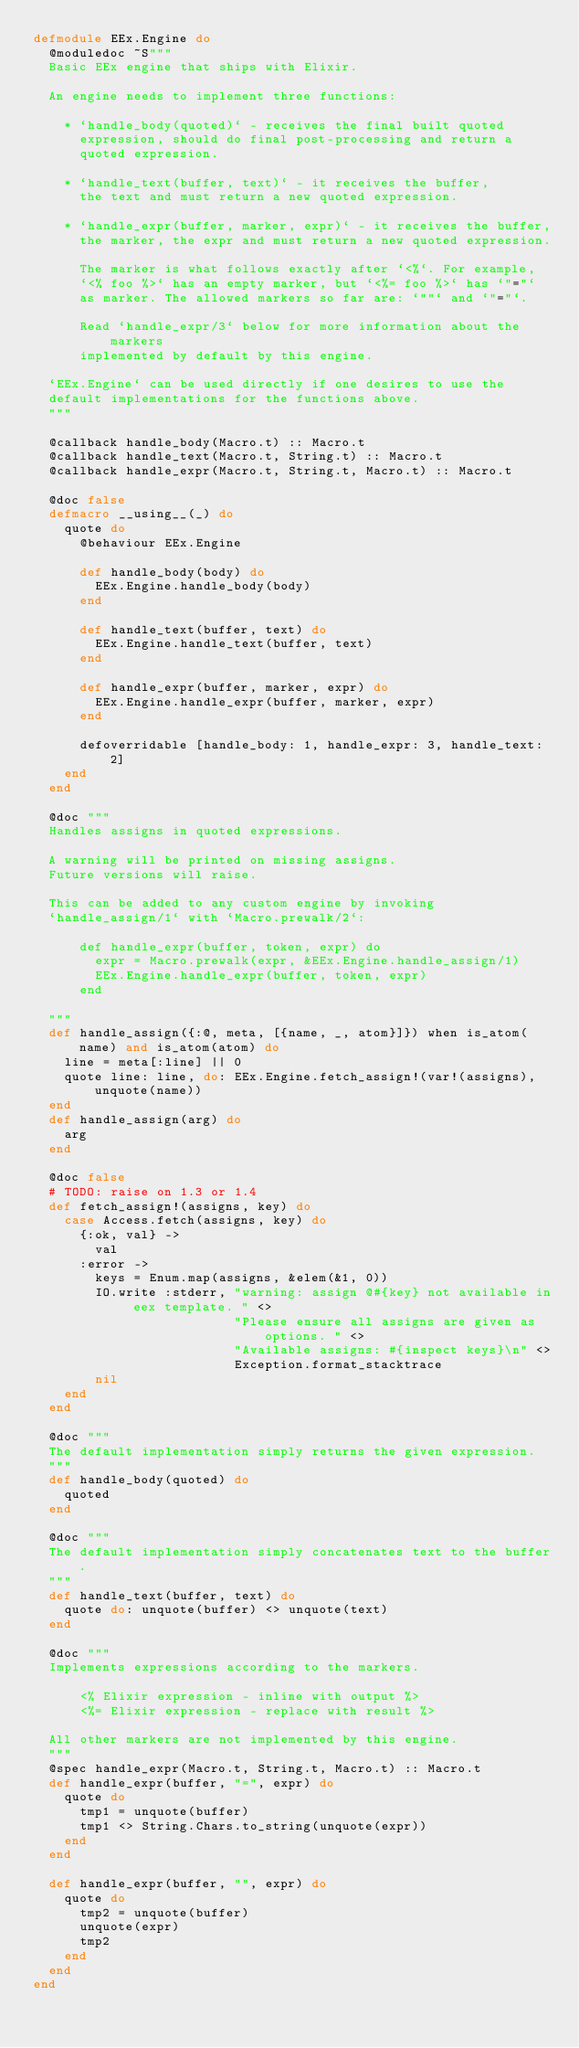Convert code to text. <code><loc_0><loc_0><loc_500><loc_500><_Elixir_>defmodule EEx.Engine do
  @moduledoc ~S"""
  Basic EEx engine that ships with Elixir.

  An engine needs to implement three functions:

    * `handle_body(quoted)` - receives the final built quoted
      expression, should do final post-processing and return a
      quoted expression.

    * `handle_text(buffer, text)` - it receives the buffer,
      the text and must return a new quoted expression.

    * `handle_expr(buffer, marker, expr)` - it receives the buffer,
      the marker, the expr and must return a new quoted expression.

      The marker is what follows exactly after `<%`. For example,
      `<% foo %>` has an empty marker, but `<%= foo %>` has `"="`
      as marker. The allowed markers so far are: `""` and `"="`.

      Read `handle_expr/3` below for more information about the markers
      implemented by default by this engine.

  `EEx.Engine` can be used directly if one desires to use the
  default implementations for the functions above.
  """

  @callback handle_body(Macro.t) :: Macro.t
  @callback handle_text(Macro.t, String.t) :: Macro.t
  @callback handle_expr(Macro.t, String.t, Macro.t) :: Macro.t

  @doc false
  defmacro __using__(_) do
    quote do
      @behaviour EEx.Engine

      def handle_body(body) do
        EEx.Engine.handle_body(body)
      end

      def handle_text(buffer, text) do
        EEx.Engine.handle_text(buffer, text)
      end

      def handle_expr(buffer, marker, expr) do
        EEx.Engine.handle_expr(buffer, marker, expr)
      end

      defoverridable [handle_body: 1, handle_expr: 3, handle_text: 2]
    end
  end

  @doc """
  Handles assigns in quoted expressions.

  A warning will be printed on missing assigns.
  Future versions will raise.

  This can be added to any custom engine by invoking
  `handle_assign/1` with `Macro.prewalk/2`:

      def handle_expr(buffer, token, expr) do
        expr = Macro.prewalk(expr, &EEx.Engine.handle_assign/1)
        EEx.Engine.handle_expr(buffer, token, expr)
      end

  """
  def handle_assign({:@, meta, [{name, _, atom}]}) when is_atom(name) and is_atom(atom) do
    line = meta[:line] || 0
    quote line: line, do: EEx.Engine.fetch_assign!(var!(assigns), unquote(name))
  end
  def handle_assign(arg) do
    arg
  end

  @doc false
  # TODO: raise on 1.3 or 1.4
  def fetch_assign!(assigns, key) do
    case Access.fetch(assigns, key) do
      {:ok, val} ->
        val
      :error ->
        keys = Enum.map(assigns, &elem(&1, 0))
        IO.write :stderr, "warning: assign @#{key} not available in eex template. " <>
                          "Please ensure all assigns are given as options. " <>
                          "Available assigns: #{inspect keys}\n" <>
                          Exception.format_stacktrace
        nil
    end
  end

  @doc """
  The default implementation simply returns the given expression.
  """
  def handle_body(quoted) do
    quoted
  end

  @doc """
  The default implementation simply concatenates text to the buffer.
  """
  def handle_text(buffer, text) do
    quote do: unquote(buffer) <> unquote(text)
  end

  @doc """
  Implements expressions according to the markers.

      <% Elixir expression - inline with output %>
      <%= Elixir expression - replace with result %>

  All other markers are not implemented by this engine.
  """
  @spec handle_expr(Macro.t, String.t, Macro.t) :: Macro.t
  def handle_expr(buffer, "=", expr) do
    quote do
      tmp1 = unquote(buffer)
      tmp1 <> String.Chars.to_string(unquote(expr))
    end
  end

  def handle_expr(buffer, "", expr) do
    quote do
      tmp2 = unquote(buffer)
      unquote(expr)
      tmp2
    end
  end
end
</code> 